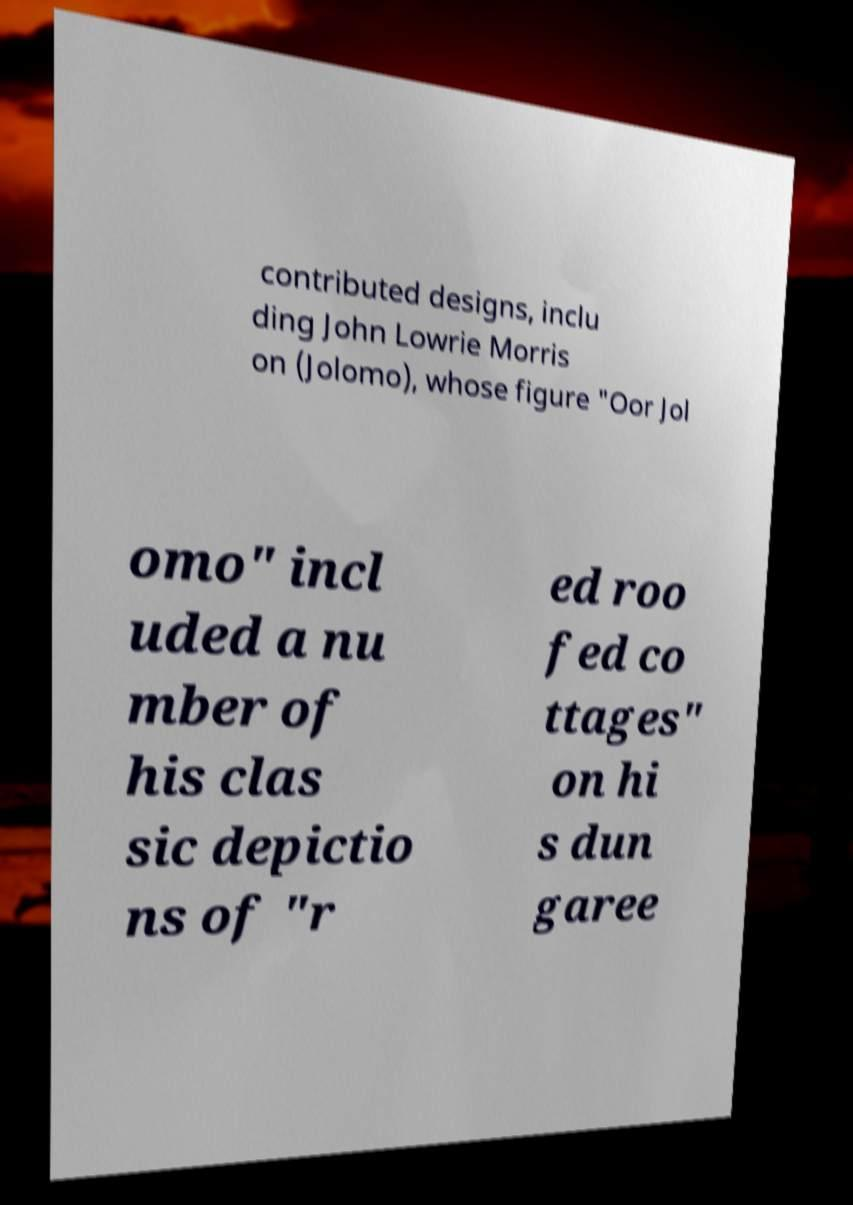Please identify and transcribe the text found in this image. contributed designs, inclu ding John Lowrie Morris on (Jolomo), whose figure "Oor Jol omo" incl uded a nu mber of his clas sic depictio ns of "r ed roo fed co ttages" on hi s dun garee 